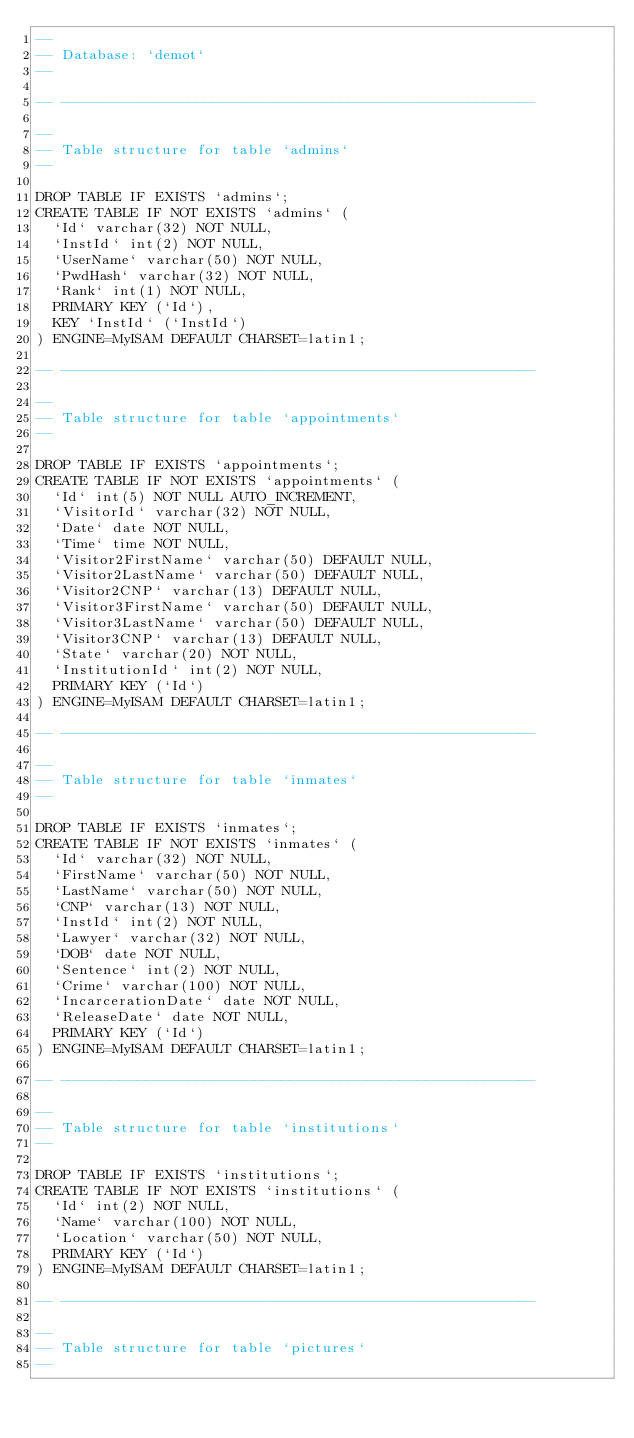Convert code to text. <code><loc_0><loc_0><loc_500><loc_500><_SQL_>--
-- Database: `demot`
--

-- --------------------------------------------------------

--
-- Table structure for table `admins`
--

DROP TABLE IF EXISTS `admins`;
CREATE TABLE IF NOT EXISTS `admins` (
  `Id` varchar(32) NOT NULL,
  `InstId` int(2) NOT NULL,
  `UserName` varchar(50) NOT NULL,
  `PwdHash` varchar(32) NOT NULL,
  `Rank` int(1) NOT NULL,
  PRIMARY KEY (`Id`),
  KEY `InstId` (`InstId`)
) ENGINE=MyISAM DEFAULT CHARSET=latin1;

-- --------------------------------------------------------

--
-- Table structure for table `appointments`
--

DROP TABLE IF EXISTS `appointments`;
CREATE TABLE IF NOT EXISTS `appointments` (
  `Id` int(5) NOT NULL AUTO_INCREMENT,
  `VisitorId` varchar(32) NOT NULL,
  `Date` date NOT NULL,
  `Time` time NOT NULL,
  `Visitor2FirstName` varchar(50) DEFAULT NULL,
  `Visitor2LastName` varchar(50) DEFAULT NULL,
  `Visitor2CNP` varchar(13) DEFAULT NULL,
  `Visitor3FirstName` varchar(50) DEFAULT NULL,
  `Visitor3LastName` varchar(50) DEFAULT NULL,
  `Visitor3CNP` varchar(13) DEFAULT NULL,
  `State` varchar(20) NOT NULL,
  `InstitutionId` int(2) NOT NULL,
  PRIMARY KEY (`Id`)
) ENGINE=MyISAM DEFAULT CHARSET=latin1;

-- --------------------------------------------------------

--
-- Table structure for table `inmates`
--

DROP TABLE IF EXISTS `inmates`;
CREATE TABLE IF NOT EXISTS `inmates` (
  `Id` varchar(32) NOT NULL,
  `FirstName` varchar(50) NOT NULL,
  `LastName` varchar(50) NOT NULL,
  `CNP` varchar(13) NOT NULL,
  `InstId` int(2) NOT NULL,
  `Lawyer` varchar(32) NOT NULL,
  `DOB` date NOT NULL,
  `Sentence` int(2) NOT NULL,
  `Crime` varchar(100) NOT NULL,
  `IncarcerationDate` date NOT NULL,
  `ReleaseDate` date NOT NULL,
  PRIMARY KEY (`Id`)
) ENGINE=MyISAM DEFAULT CHARSET=latin1;

-- --------------------------------------------------------

--
-- Table structure for table `institutions`
--

DROP TABLE IF EXISTS `institutions`;
CREATE TABLE IF NOT EXISTS `institutions` (
  `Id` int(2) NOT NULL,
  `Name` varchar(100) NOT NULL,
  `Location` varchar(50) NOT NULL,
  PRIMARY KEY (`Id`)
) ENGINE=MyISAM DEFAULT CHARSET=latin1;

-- --------------------------------------------------------

--
-- Table structure for table `pictures`
--
</code> 